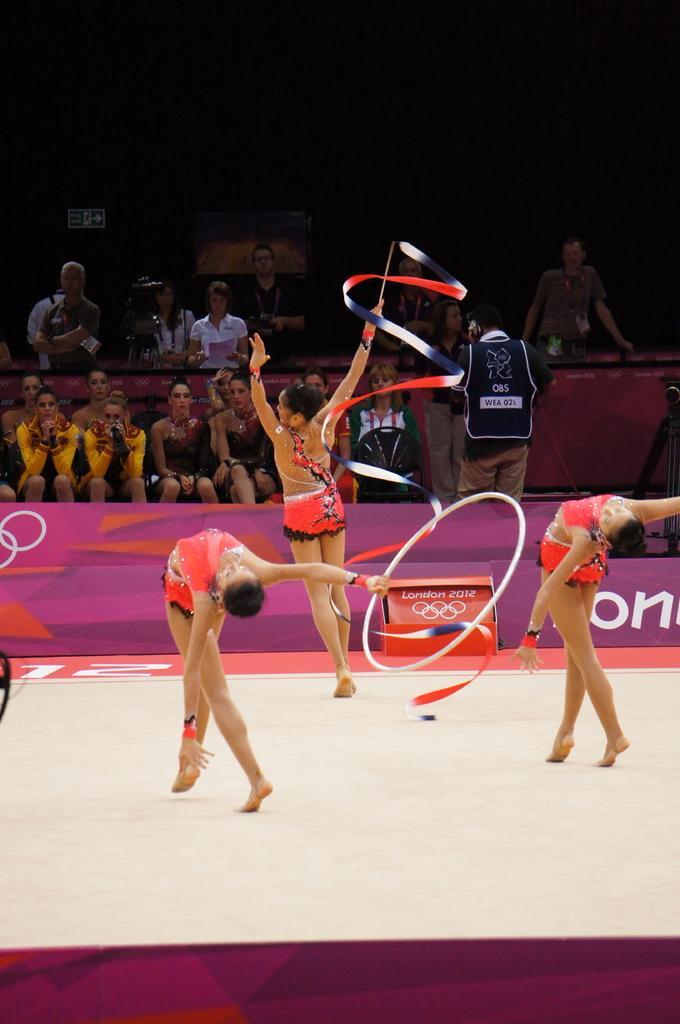How would you summarize this image in a sentence or two? In this image I can see group of people. In front the person is holding the ring. In the background I can see few people, some are sitting and some are standing and I can also see the board. 